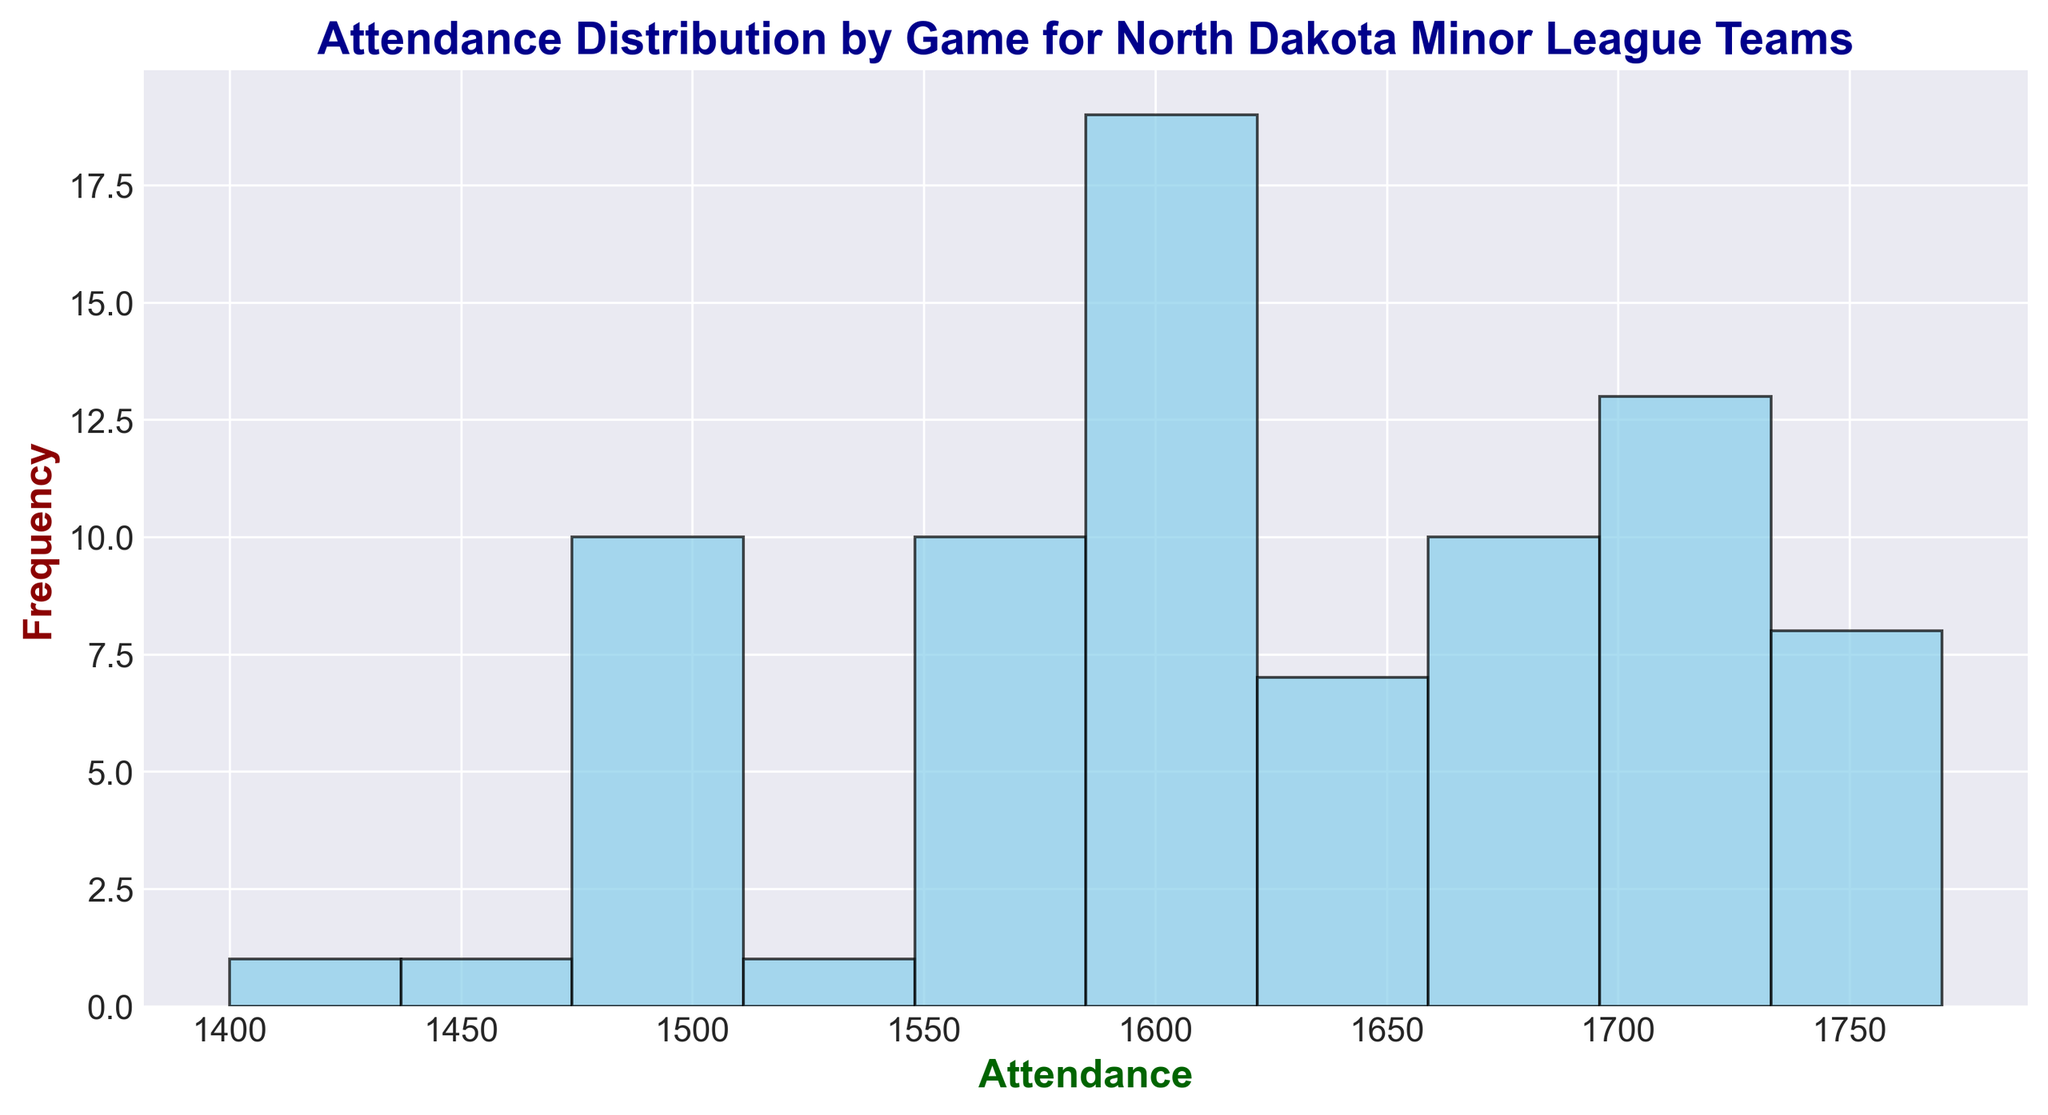What's the most common range of attendance? Look at the tallest bar in the histogram, which represents the most frequent (mode) attendance range.
Answer: 1600-1650 How many games had an attendance of 1650-1700? Identify the bar corresponding to the range 1650-1700 and read its height to determine the frequency.
Answer: 11 Is the attendance of 1700-1750 more frequent than the attendance of 1500-1550? Compare the heights of the bars for the ranges 1700-1750 and 1500-1550.
Answer: Yes What's the median range of attendance? Since the data is fairly evenly spread, the median range will be around the middle value. Visualize the bars divided, and notice that the central area will correspond to the 1600-1650 range.
Answer: 1600-1650 Which attendance range has the least frequency? Look for the shortest bars in the histogram and identify their ranges.
Answer: 1450-1500 What percentage of games had attendance greater than 1600? Find the total number of instances (80 games). Count the frequencies of bars with attendance ranges above 1600 and divide by the total, then multiply by 100 to get the percentage.
Answer: (33/80)*100 = 41.25% What is the total number of games with attendances between 1550 and 1650? Add the frequencies of all bars corresponding to the ranges 1550-1600, 1600-1650.
Answer: 26 games How does the frequency of games with attendance 1550-1600 compare to those with attendance 1600-1650? Compare the heights of the bars for 1550-1600 and 1600-1650 ranges.
Answer: Less What is the highest attendance recorded? Look at the histogram's x-axis to identify the farthest point to the right where there is a bar representing attendance.
Answer: 1770 What is the overall range of attendance? Look at the minimum and maximum values on the x-axis covered by the bars.
Answer: 1400-1770 